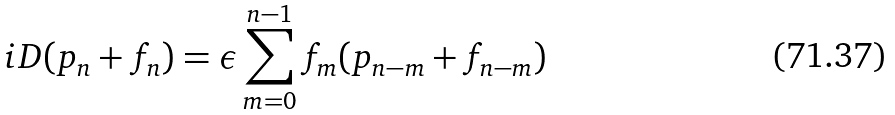Convert formula to latex. <formula><loc_0><loc_0><loc_500><loc_500>i D ( p _ { n } + f _ { n } ) = \epsilon \sum _ { m = 0 } ^ { n - 1 } f _ { m } ( p _ { n - m } + f _ { n - m } )</formula> 